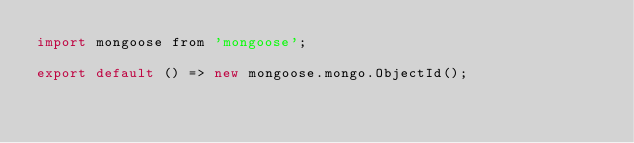Convert code to text. <code><loc_0><loc_0><loc_500><loc_500><_JavaScript_>import mongoose from 'mongoose';

export default () => new mongoose.mongo.ObjectId();
</code> 